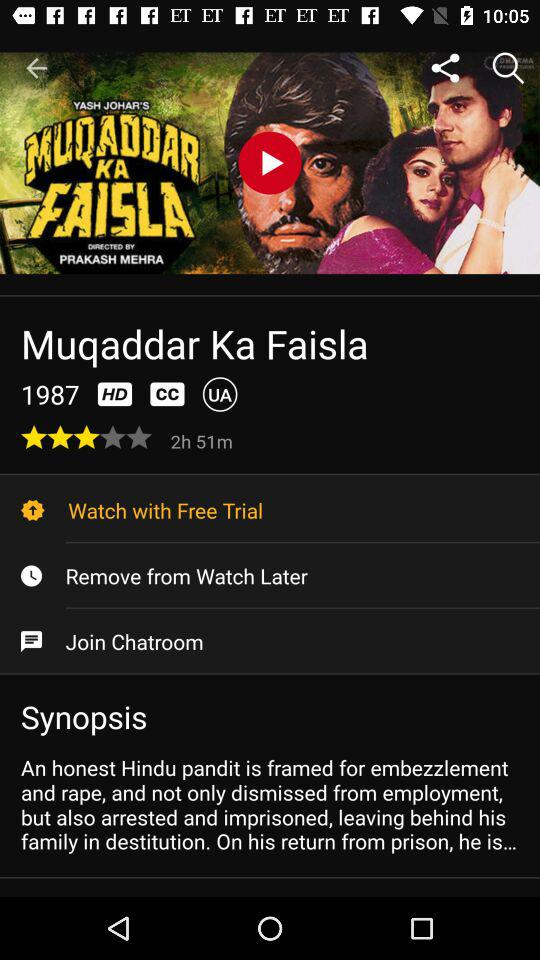What is the title of the movie? The title of the movie is "Muqaddar Ka Faisla". 